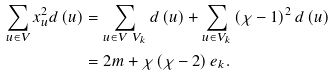<formula> <loc_0><loc_0><loc_500><loc_500>\sum _ { u \in V } x _ { u } ^ { 2 } d \left ( u \right ) & = \sum _ { u \in V \ V _ { k } } d \left ( u \right ) + \sum _ { u \in V _ { k } } \left ( \chi - 1 \right ) ^ { 2 } d \left ( u \right ) \\ & = 2 m + \chi \left ( \chi - 2 \right ) e _ { k } .</formula> 